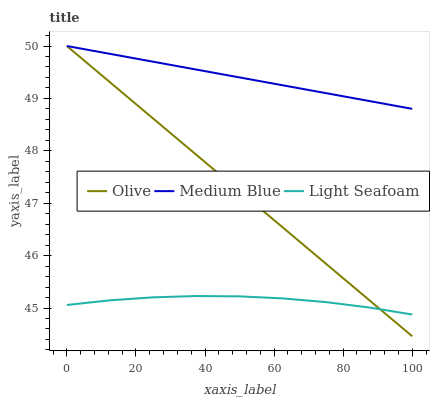Does Light Seafoam have the minimum area under the curve?
Answer yes or no. Yes. Does Medium Blue have the maximum area under the curve?
Answer yes or no. Yes. Does Medium Blue have the minimum area under the curve?
Answer yes or no. No. Does Light Seafoam have the maximum area under the curve?
Answer yes or no. No. Is Medium Blue the smoothest?
Answer yes or no. Yes. Is Light Seafoam the roughest?
Answer yes or no. Yes. Is Light Seafoam the smoothest?
Answer yes or no. No. Is Medium Blue the roughest?
Answer yes or no. No. Does Olive have the lowest value?
Answer yes or no. Yes. Does Light Seafoam have the lowest value?
Answer yes or no. No. Does Medium Blue have the highest value?
Answer yes or no. Yes. Does Light Seafoam have the highest value?
Answer yes or no. No. Is Light Seafoam less than Medium Blue?
Answer yes or no. Yes. Is Medium Blue greater than Light Seafoam?
Answer yes or no. Yes. Does Olive intersect Medium Blue?
Answer yes or no. Yes. Is Olive less than Medium Blue?
Answer yes or no. No. Is Olive greater than Medium Blue?
Answer yes or no. No. Does Light Seafoam intersect Medium Blue?
Answer yes or no. No. 